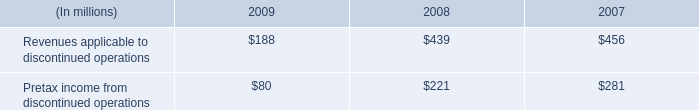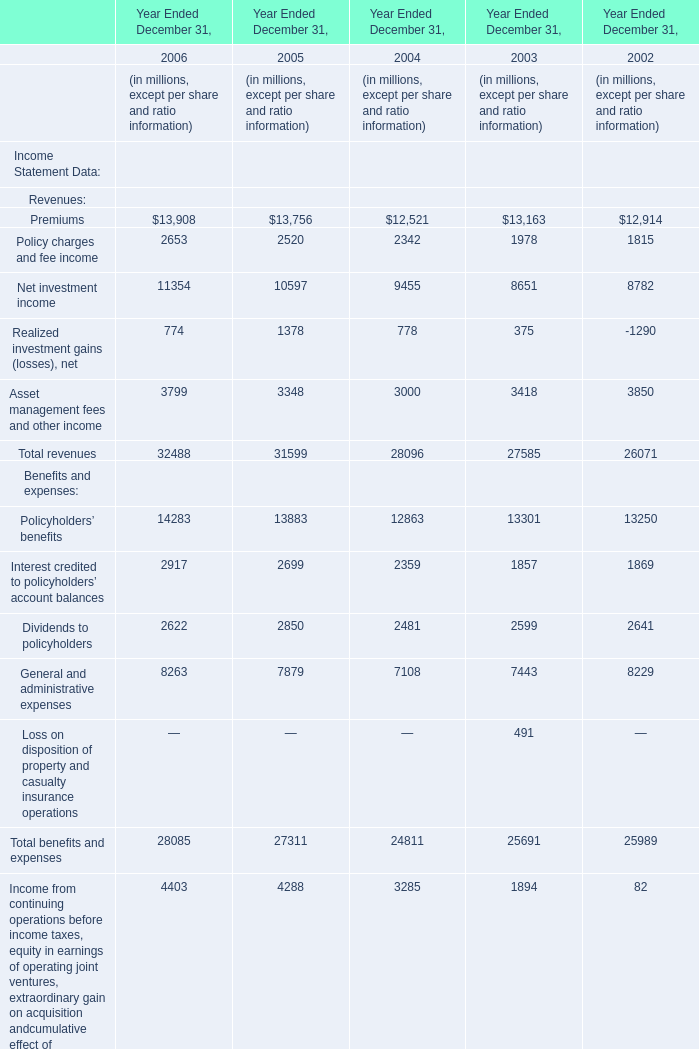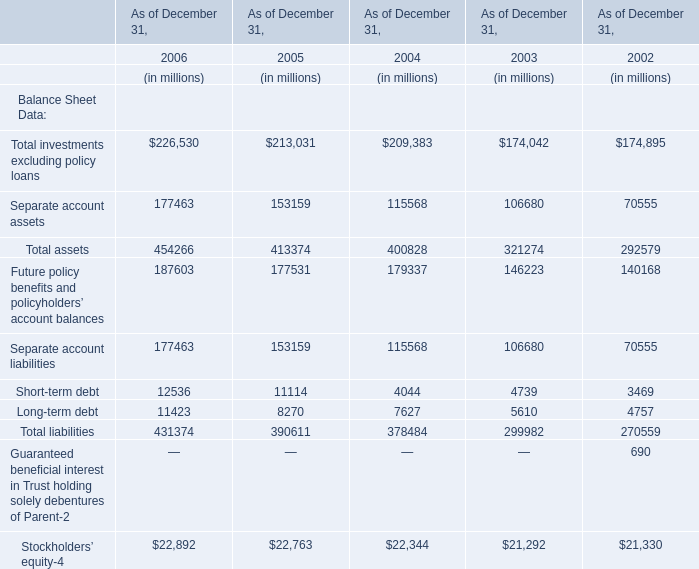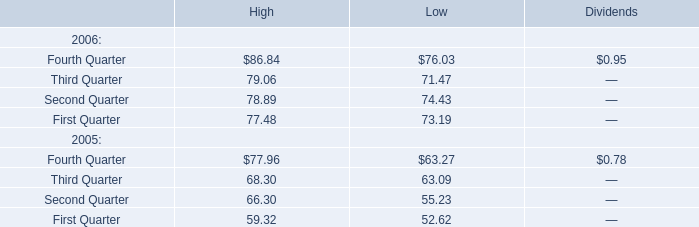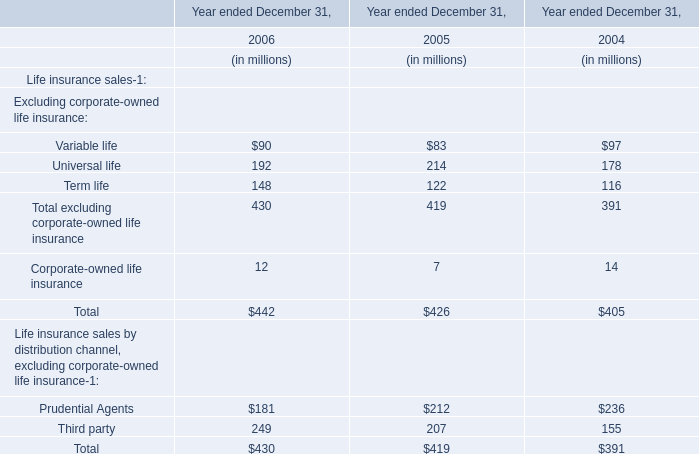What was the total amount of Total investments excluding policy loansSeparate account assetsTotal assetsFuture policy benefits and policyholders’ account balances in 2006? (in million) 
Computations: (((226530 + 177463) + 454266) + 187603)
Answer: 1045862.0. 